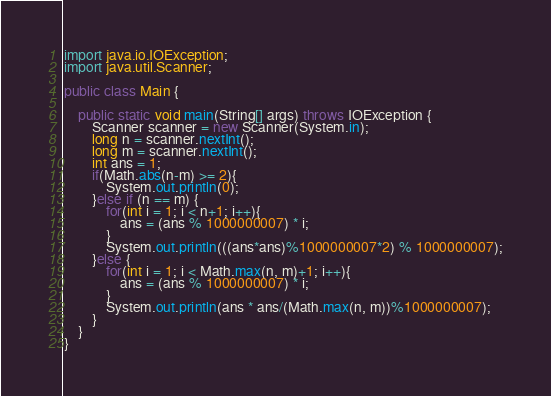Convert code to text. <code><loc_0><loc_0><loc_500><loc_500><_Java_>import java.io.IOException;
import java.util.Scanner;

public class Main {

	public static void main(String[] args) throws IOException {
		Scanner scanner = new Scanner(System.in);
		long n = scanner.nextInt();
		long m = scanner.nextInt();
		int ans = 1;
		if(Math.abs(n-m) >= 2){
			System.out.println(0);
		}else if (n == m) {
			for(int i = 1; i < n+1; i++){
				ans = (ans % 1000000007) * i;
			}
			System.out.println(((ans*ans)%1000000007*2) % 1000000007);
		}else {
			for(int i = 1; i < Math.max(n, m)+1; i++){
				ans = (ans % 1000000007) * i;
			}
			System.out.println(ans * ans/(Math.max(n, m))%1000000007);
		}
	}
}
</code> 